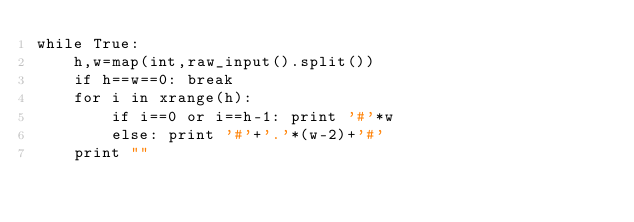<code> <loc_0><loc_0><loc_500><loc_500><_Python_>while True:
	h,w=map(int,raw_input().split())
	if h==w==0: break
	for i in xrange(h):
		if i==0 or i==h-1: print '#'*w
		else: print '#'+'.'*(w-2)+'#'
	print ""</code> 